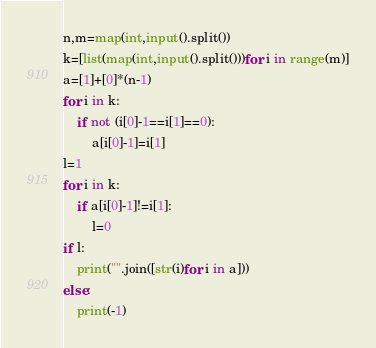<code> <loc_0><loc_0><loc_500><loc_500><_Python_>n,m=map(int,input().split())
k=[list(map(int,input().split()))for i in range(m)]
a=[1]+[0]*(n-1)
for i in k:
    if not (i[0]-1==i[1]==0):
        a[i[0]-1]=i[1]
l=1
for i in k:
    if a[i[0]-1]!=i[1]:
        l=0
if l:
    print("".join([str(i)for i in a]))
else:
    print(-1)</code> 